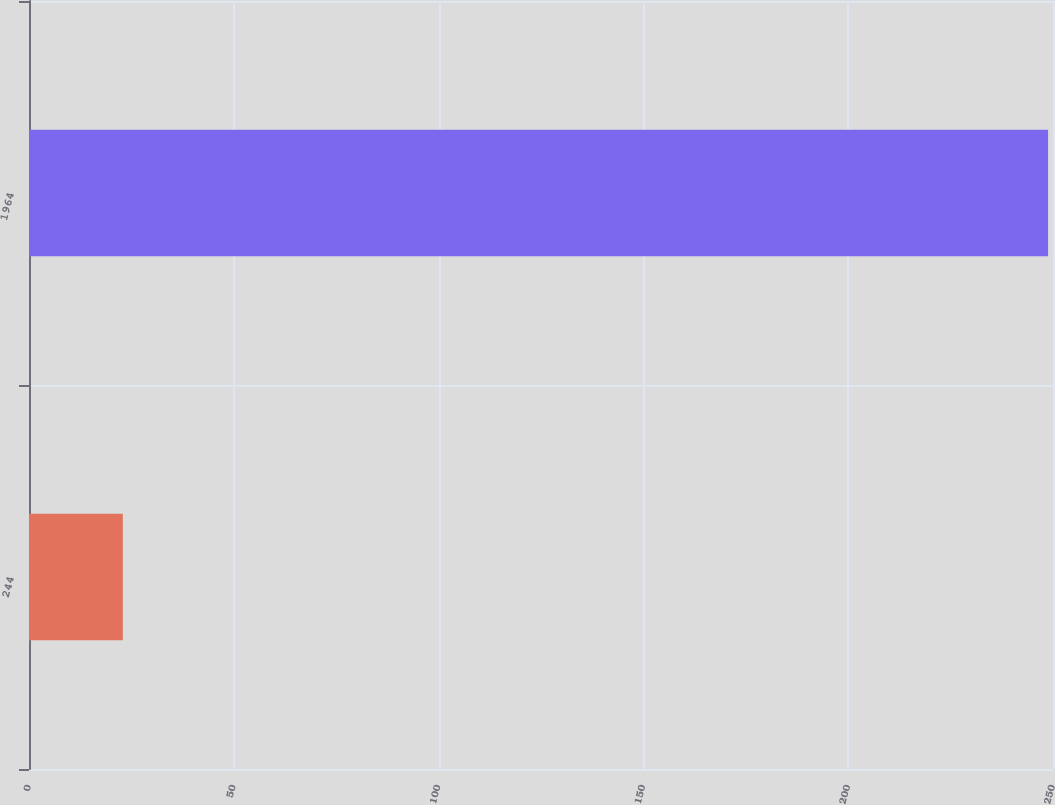Convert chart. <chart><loc_0><loc_0><loc_500><loc_500><bar_chart><fcel>244<fcel>1964<nl><fcel>22.9<fcel>248.8<nl></chart> 